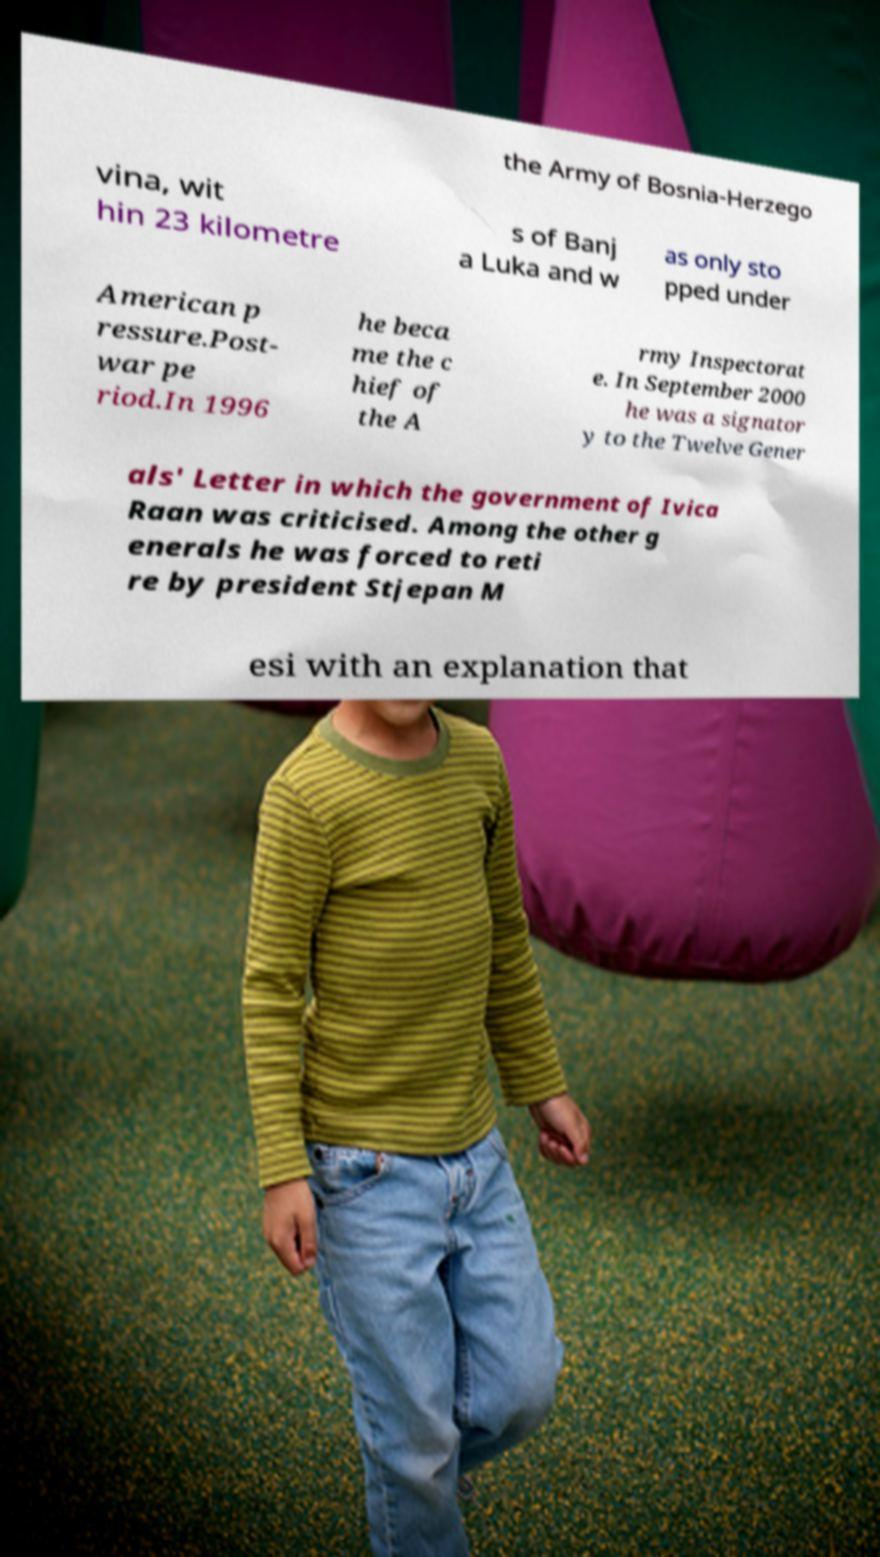Please identify and transcribe the text found in this image. the Army of Bosnia-Herzego vina, wit hin 23 kilometre s of Banj a Luka and w as only sto pped under American p ressure.Post- war pe riod.In 1996 he beca me the c hief of the A rmy Inspectorat e. In September 2000 he was a signator y to the Twelve Gener als' Letter in which the government of Ivica Raan was criticised. Among the other g enerals he was forced to reti re by president Stjepan M esi with an explanation that 